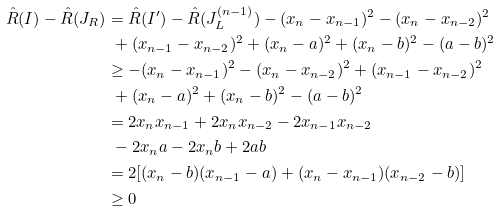<formula> <loc_0><loc_0><loc_500><loc_500>\hat { R } ( I ) - \hat { R } ( J _ { R } ) & = \hat { R } ( I ^ { \prime } ) - \hat { R } ( J _ { L } ^ { ( n - 1 ) } ) - ( x _ { n } - x _ { n - 1 } ) ^ { 2 } - ( x _ { n } - x _ { n - 2 } ) ^ { 2 } \\ & \ + ( x _ { n - 1 } - x _ { n - 2 } ) ^ { 2 } + ( x _ { n } - a ) ^ { 2 } + ( x _ { n } - b ) ^ { 2 } - ( a - b ) ^ { 2 } \\ & \geq - ( x _ { n } - x _ { n - 1 } ) ^ { 2 } - ( x _ { n } - x _ { n - 2 } ) ^ { 2 } + ( x _ { n - 1 } - x _ { n - 2 } ) ^ { 2 } \\ & \ + ( x _ { n } - a ) ^ { 2 } + ( x _ { n } - b ) ^ { 2 } - ( a - b ) ^ { 2 } \\ & = 2 x _ { n } x _ { n - 1 } + 2 x _ { n } x _ { n - 2 } - 2 x _ { n - 1 } x _ { n - 2 } \\ & \ - 2 x _ { n } a - 2 x _ { n } b + 2 a b \\ & = 2 [ ( x _ { n } - b ) ( x _ { n - 1 } - a ) + ( x _ { n } - x _ { n - 1 } ) ( x _ { n - 2 } - b ) ] \\ & \geq 0</formula> 